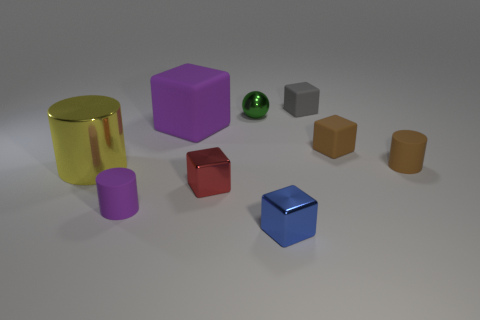There is a rubber cylinder that is the same color as the large rubber block; what is its size?
Give a very brief answer. Small. The small object that is the same color as the big rubber thing is what shape?
Offer a terse response. Cylinder. There is another metal block that is the same size as the blue metallic cube; what is its color?
Ensure brevity in your answer.  Red. How many tiny objects are on the right side of the tiny green shiny object and in front of the yellow shiny cylinder?
Keep it short and to the point. 1. What is the blue thing made of?
Provide a succinct answer. Metal. How many things are small gray metallic cylinders or matte objects?
Ensure brevity in your answer.  5. There is a matte cylinder on the left side of the tiny green metallic object; does it have the same size as the matte block that is left of the blue shiny block?
Keep it short and to the point. No. How many other things are there of the same size as the green metallic ball?
Make the answer very short. 6. What number of things are tiny metal things behind the small blue metallic block or blocks that are behind the blue metallic cube?
Your response must be concise. 5. Is the blue thing made of the same material as the big thing in front of the large purple rubber cube?
Provide a succinct answer. Yes. 